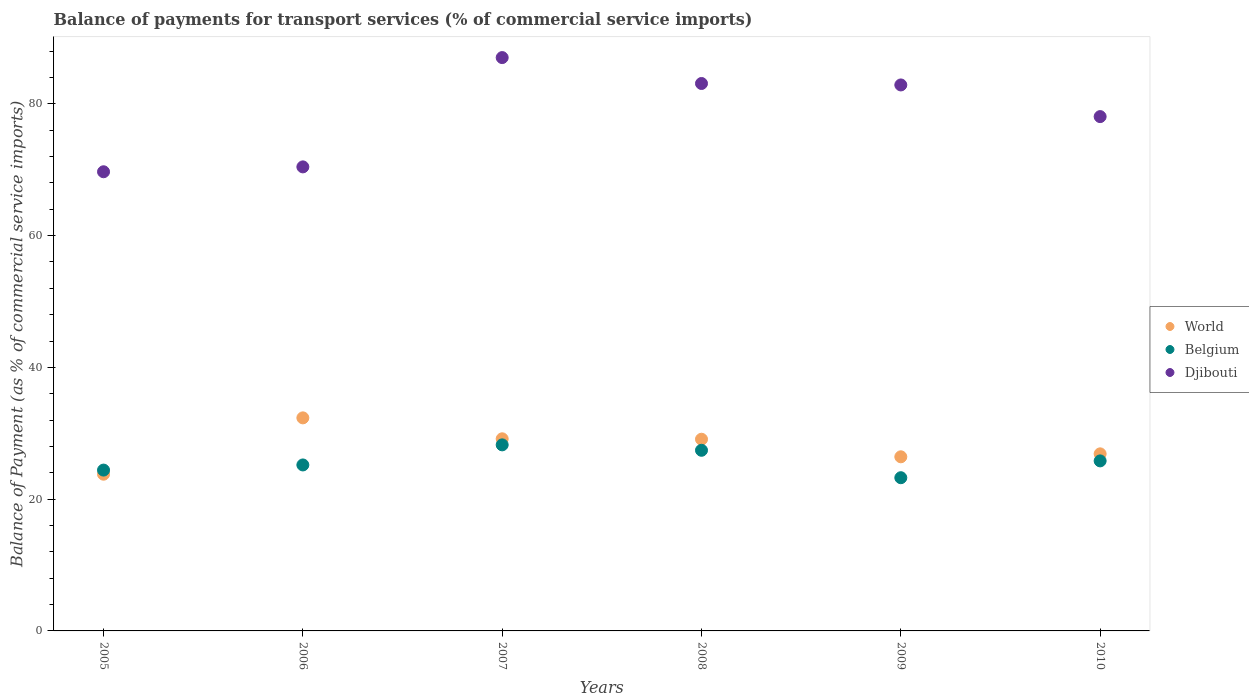How many different coloured dotlines are there?
Provide a succinct answer. 3. Is the number of dotlines equal to the number of legend labels?
Your answer should be compact. Yes. What is the balance of payments for transport services in Belgium in 2009?
Make the answer very short. 23.26. Across all years, what is the maximum balance of payments for transport services in World?
Ensure brevity in your answer.  32.34. Across all years, what is the minimum balance of payments for transport services in World?
Give a very brief answer. 23.79. What is the total balance of payments for transport services in Djibouti in the graph?
Provide a succinct answer. 471.19. What is the difference between the balance of payments for transport services in Djibouti in 2005 and that in 2006?
Your answer should be compact. -0.74. What is the difference between the balance of payments for transport services in World in 2006 and the balance of payments for transport services in Djibouti in 2009?
Offer a very short reply. -50.53. What is the average balance of payments for transport services in World per year?
Your response must be concise. 27.95. In the year 2006, what is the difference between the balance of payments for transport services in World and balance of payments for transport services in Belgium?
Offer a very short reply. 7.15. In how many years, is the balance of payments for transport services in World greater than 16 %?
Make the answer very short. 6. What is the ratio of the balance of payments for transport services in World in 2007 to that in 2010?
Keep it short and to the point. 1.08. Is the balance of payments for transport services in Belgium in 2009 less than that in 2010?
Make the answer very short. Yes. Is the difference between the balance of payments for transport services in World in 2005 and 2006 greater than the difference between the balance of payments for transport services in Belgium in 2005 and 2006?
Give a very brief answer. No. What is the difference between the highest and the second highest balance of payments for transport services in Belgium?
Offer a terse response. 0.82. What is the difference between the highest and the lowest balance of payments for transport services in Belgium?
Make the answer very short. 4.99. Is the sum of the balance of payments for transport services in Belgium in 2005 and 2008 greater than the maximum balance of payments for transport services in Djibouti across all years?
Give a very brief answer. No. Does the balance of payments for transport services in World monotonically increase over the years?
Provide a succinct answer. No. Is the balance of payments for transport services in Belgium strictly greater than the balance of payments for transport services in Djibouti over the years?
Give a very brief answer. No. How many dotlines are there?
Provide a succinct answer. 3. How many years are there in the graph?
Your response must be concise. 6. Are the values on the major ticks of Y-axis written in scientific E-notation?
Ensure brevity in your answer.  No. Where does the legend appear in the graph?
Keep it short and to the point. Center right. How many legend labels are there?
Offer a terse response. 3. How are the legend labels stacked?
Your answer should be very brief. Vertical. What is the title of the graph?
Offer a terse response. Balance of payments for transport services (% of commercial service imports). Does "Jordan" appear as one of the legend labels in the graph?
Your answer should be very brief. No. What is the label or title of the X-axis?
Your answer should be very brief. Years. What is the label or title of the Y-axis?
Your response must be concise. Balance of Payment (as % of commercial service imports). What is the Balance of Payment (as % of commercial service imports) in World in 2005?
Your response must be concise. 23.79. What is the Balance of Payment (as % of commercial service imports) in Belgium in 2005?
Your answer should be compact. 24.41. What is the Balance of Payment (as % of commercial service imports) in Djibouti in 2005?
Offer a terse response. 69.7. What is the Balance of Payment (as % of commercial service imports) of World in 2006?
Give a very brief answer. 32.34. What is the Balance of Payment (as % of commercial service imports) of Belgium in 2006?
Offer a terse response. 25.19. What is the Balance of Payment (as % of commercial service imports) in Djibouti in 2006?
Provide a short and direct response. 70.44. What is the Balance of Payment (as % of commercial service imports) of World in 2007?
Your answer should be very brief. 29.16. What is the Balance of Payment (as % of commercial service imports) of Belgium in 2007?
Offer a very short reply. 28.24. What is the Balance of Payment (as % of commercial service imports) in Djibouti in 2007?
Give a very brief answer. 87.03. What is the Balance of Payment (as % of commercial service imports) in World in 2008?
Provide a succinct answer. 29.1. What is the Balance of Payment (as % of commercial service imports) of Belgium in 2008?
Offer a very short reply. 27.42. What is the Balance of Payment (as % of commercial service imports) in Djibouti in 2008?
Provide a short and direct response. 83.09. What is the Balance of Payment (as % of commercial service imports) in World in 2009?
Your response must be concise. 26.43. What is the Balance of Payment (as % of commercial service imports) of Belgium in 2009?
Give a very brief answer. 23.26. What is the Balance of Payment (as % of commercial service imports) of Djibouti in 2009?
Your response must be concise. 82.87. What is the Balance of Payment (as % of commercial service imports) of World in 2010?
Your answer should be compact. 26.88. What is the Balance of Payment (as % of commercial service imports) in Belgium in 2010?
Make the answer very short. 25.81. What is the Balance of Payment (as % of commercial service imports) of Djibouti in 2010?
Provide a short and direct response. 78.07. Across all years, what is the maximum Balance of Payment (as % of commercial service imports) in World?
Offer a terse response. 32.34. Across all years, what is the maximum Balance of Payment (as % of commercial service imports) of Belgium?
Your response must be concise. 28.24. Across all years, what is the maximum Balance of Payment (as % of commercial service imports) in Djibouti?
Offer a very short reply. 87.03. Across all years, what is the minimum Balance of Payment (as % of commercial service imports) of World?
Ensure brevity in your answer.  23.79. Across all years, what is the minimum Balance of Payment (as % of commercial service imports) in Belgium?
Ensure brevity in your answer.  23.26. Across all years, what is the minimum Balance of Payment (as % of commercial service imports) in Djibouti?
Offer a very short reply. 69.7. What is the total Balance of Payment (as % of commercial service imports) in World in the graph?
Make the answer very short. 167.7. What is the total Balance of Payment (as % of commercial service imports) in Belgium in the graph?
Give a very brief answer. 154.33. What is the total Balance of Payment (as % of commercial service imports) of Djibouti in the graph?
Give a very brief answer. 471.19. What is the difference between the Balance of Payment (as % of commercial service imports) in World in 2005 and that in 2006?
Your response must be concise. -8.55. What is the difference between the Balance of Payment (as % of commercial service imports) in Belgium in 2005 and that in 2006?
Give a very brief answer. -0.78. What is the difference between the Balance of Payment (as % of commercial service imports) in Djibouti in 2005 and that in 2006?
Your answer should be very brief. -0.74. What is the difference between the Balance of Payment (as % of commercial service imports) in World in 2005 and that in 2007?
Provide a short and direct response. -5.37. What is the difference between the Balance of Payment (as % of commercial service imports) in Belgium in 2005 and that in 2007?
Ensure brevity in your answer.  -3.83. What is the difference between the Balance of Payment (as % of commercial service imports) in Djibouti in 2005 and that in 2007?
Your answer should be compact. -17.33. What is the difference between the Balance of Payment (as % of commercial service imports) of World in 2005 and that in 2008?
Your answer should be very brief. -5.31. What is the difference between the Balance of Payment (as % of commercial service imports) in Belgium in 2005 and that in 2008?
Your response must be concise. -3.01. What is the difference between the Balance of Payment (as % of commercial service imports) of Djibouti in 2005 and that in 2008?
Your answer should be compact. -13.4. What is the difference between the Balance of Payment (as % of commercial service imports) of World in 2005 and that in 2009?
Keep it short and to the point. -2.64. What is the difference between the Balance of Payment (as % of commercial service imports) of Belgium in 2005 and that in 2009?
Your answer should be very brief. 1.16. What is the difference between the Balance of Payment (as % of commercial service imports) of Djibouti in 2005 and that in 2009?
Offer a terse response. -13.18. What is the difference between the Balance of Payment (as % of commercial service imports) in World in 2005 and that in 2010?
Offer a terse response. -3.09. What is the difference between the Balance of Payment (as % of commercial service imports) of Belgium in 2005 and that in 2010?
Keep it short and to the point. -1.4. What is the difference between the Balance of Payment (as % of commercial service imports) of Djibouti in 2005 and that in 2010?
Keep it short and to the point. -8.37. What is the difference between the Balance of Payment (as % of commercial service imports) in World in 2006 and that in 2007?
Offer a terse response. 3.18. What is the difference between the Balance of Payment (as % of commercial service imports) of Belgium in 2006 and that in 2007?
Keep it short and to the point. -3.05. What is the difference between the Balance of Payment (as % of commercial service imports) in Djibouti in 2006 and that in 2007?
Give a very brief answer. -16.59. What is the difference between the Balance of Payment (as % of commercial service imports) in World in 2006 and that in 2008?
Make the answer very short. 3.24. What is the difference between the Balance of Payment (as % of commercial service imports) in Belgium in 2006 and that in 2008?
Offer a terse response. -2.22. What is the difference between the Balance of Payment (as % of commercial service imports) of Djibouti in 2006 and that in 2008?
Your answer should be compact. -12.66. What is the difference between the Balance of Payment (as % of commercial service imports) of World in 2006 and that in 2009?
Provide a succinct answer. 5.91. What is the difference between the Balance of Payment (as % of commercial service imports) in Belgium in 2006 and that in 2009?
Provide a short and direct response. 1.94. What is the difference between the Balance of Payment (as % of commercial service imports) of Djibouti in 2006 and that in 2009?
Give a very brief answer. -12.44. What is the difference between the Balance of Payment (as % of commercial service imports) in World in 2006 and that in 2010?
Your answer should be very brief. 5.46. What is the difference between the Balance of Payment (as % of commercial service imports) of Belgium in 2006 and that in 2010?
Your answer should be very brief. -0.61. What is the difference between the Balance of Payment (as % of commercial service imports) of Djibouti in 2006 and that in 2010?
Offer a very short reply. -7.63. What is the difference between the Balance of Payment (as % of commercial service imports) in World in 2007 and that in 2008?
Your answer should be compact. 0.06. What is the difference between the Balance of Payment (as % of commercial service imports) in Belgium in 2007 and that in 2008?
Give a very brief answer. 0.82. What is the difference between the Balance of Payment (as % of commercial service imports) in Djibouti in 2007 and that in 2008?
Make the answer very short. 3.93. What is the difference between the Balance of Payment (as % of commercial service imports) in World in 2007 and that in 2009?
Keep it short and to the point. 2.73. What is the difference between the Balance of Payment (as % of commercial service imports) in Belgium in 2007 and that in 2009?
Keep it short and to the point. 4.99. What is the difference between the Balance of Payment (as % of commercial service imports) in Djibouti in 2007 and that in 2009?
Offer a terse response. 4.15. What is the difference between the Balance of Payment (as % of commercial service imports) of World in 2007 and that in 2010?
Keep it short and to the point. 2.28. What is the difference between the Balance of Payment (as % of commercial service imports) in Belgium in 2007 and that in 2010?
Your answer should be compact. 2.43. What is the difference between the Balance of Payment (as % of commercial service imports) in Djibouti in 2007 and that in 2010?
Provide a short and direct response. 8.96. What is the difference between the Balance of Payment (as % of commercial service imports) in World in 2008 and that in 2009?
Provide a short and direct response. 2.67. What is the difference between the Balance of Payment (as % of commercial service imports) of Belgium in 2008 and that in 2009?
Provide a short and direct response. 4.16. What is the difference between the Balance of Payment (as % of commercial service imports) in Djibouti in 2008 and that in 2009?
Your answer should be very brief. 0.22. What is the difference between the Balance of Payment (as % of commercial service imports) of World in 2008 and that in 2010?
Make the answer very short. 2.22. What is the difference between the Balance of Payment (as % of commercial service imports) of Belgium in 2008 and that in 2010?
Offer a terse response. 1.61. What is the difference between the Balance of Payment (as % of commercial service imports) in Djibouti in 2008 and that in 2010?
Provide a succinct answer. 5.02. What is the difference between the Balance of Payment (as % of commercial service imports) of World in 2009 and that in 2010?
Keep it short and to the point. -0.45. What is the difference between the Balance of Payment (as % of commercial service imports) in Belgium in 2009 and that in 2010?
Your response must be concise. -2.55. What is the difference between the Balance of Payment (as % of commercial service imports) in Djibouti in 2009 and that in 2010?
Keep it short and to the point. 4.81. What is the difference between the Balance of Payment (as % of commercial service imports) of World in 2005 and the Balance of Payment (as % of commercial service imports) of Belgium in 2006?
Give a very brief answer. -1.4. What is the difference between the Balance of Payment (as % of commercial service imports) in World in 2005 and the Balance of Payment (as % of commercial service imports) in Djibouti in 2006?
Your answer should be compact. -46.65. What is the difference between the Balance of Payment (as % of commercial service imports) of Belgium in 2005 and the Balance of Payment (as % of commercial service imports) of Djibouti in 2006?
Your answer should be compact. -46.02. What is the difference between the Balance of Payment (as % of commercial service imports) of World in 2005 and the Balance of Payment (as % of commercial service imports) of Belgium in 2007?
Your answer should be very brief. -4.45. What is the difference between the Balance of Payment (as % of commercial service imports) of World in 2005 and the Balance of Payment (as % of commercial service imports) of Djibouti in 2007?
Offer a very short reply. -63.24. What is the difference between the Balance of Payment (as % of commercial service imports) of Belgium in 2005 and the Balance of Payment (as % of commercial service imports) of Djibouti in 2007?
Your answer should be very brief. -62.61. What is the difference between the Balance of Payment (as % of commercial service imports) in World in 2005 and the Balance of Payment (as % of commercial service imports) in Belgium in 2008?
Provide a succinct answer. -3.63. What is the difference between the Balance of Payment (as % of commercial service imports) of World in 2005 and the Balance of Payment (as % of commercial service imports) of Djibouti in 2008?
Provide a short and direct response. -59.3. What is the difference between the Balance of Payment (as % of commercial service imports) in Belgium in 2005 and the Balance of Payment (as % of commercial service imports) in Djibouti in 2008?
Your answer should be very brief. -58.68. What is the difference between the Balance of Payment (as % of commercial service imports) in World in 2005 and the Balance of Payment (as % of commercial service imports) in Belgium in 2009?
Provide a short and direct response. 0.53. What is the difference between the Balance of Payment (as % of commercial service imports) of World in 2005 and the Balance of Payment (as % of commercial service imports) of Djibouti in 2009?
Keep it short and to the point. -59.08. What is the difference between the Balance of Payment (as % of commercial service imports) of Belgium in 2005 and the Balance of Payment (as % of commercial service imports) of Djibouti in 2009?
Ensure brevity in your answer.  -58.46. What is the difference between the Balance of Payment (as % of commercial service imports) of World in 2005 and the Balance of Payment (as % of commercial service imports) of Belgium in 2010?
Your answer should be compact. -2.02. What is the difference between the Balance of Payment (as % of commercial service imports) in World in 2005 and the Balance of Payment (as % of commercial service imports) in Djibouti in 2010?
Offer a terse response. -54.28. What is the difference between the Balance of Payment (as % of commercial service imports) in Belgium in 2005 and the Balance of Payment (as % of commercial service imports) in Djibouti in 2010?
Give a very brief answer. -53.66. What is the difference between the Balance of Payment (as % of commercial service imports) of World in 2006 and the Balance of Payment (as % of commercial service imports) of Belgium in 2007?
Provide a short and direct response. 4.1. What is the difference between the Balance of Payment (as % of commercial service imports) in World in 2006 and the Balance of Payment (as % of commercial service imports) in Djibouti in 2007?
Your response must be concise. -54.69. What is the difference between the Balance of Payment (as % of commercial service imports) of Belgium in 2006 and the Balance of Payment (as % of commercial service imports) of Djibouti in 2007?
Ensure brevity in your answer.  -61.83. What is the difference between the Balance of Payment (as % of commercial service imports) of World in 2006 and the Balance of Payment (as % of commercial service imports) of Belgium in 2008?
Offer a very short reply. 4.92. What is the difference between the Balance of Payment (as % of commercial service imports) of World in 2006 and the Balance of Payment (as % of commercial service imports) of Djibouti in 2008?
Offer a very short reply. -50.75. What is the difference between the Balance of Payment (as % of commercial service imports) of Belgium in 2006 and the Balance of Payment (as % of commercial service imports) of Djibouti in 2008?
Your answer should be very brief. -57.9. What is the difference between the Balance of Payment (as % of commercial service imports) in World in 2006 and the Balance of Payment (as % of commercial service imports) in Belgium in 2009?
Provide a succinct answer. 9.08. What is the difference between the Balance of Payment (as % of commercial service imports) of World in 2006 and the Balance of Payment (as % of commercial service imports) of Djibouti in 2009?
Keep it short and to the point. -50.53. What is the difference between the Balance of Payment (as % of commercial service imports) of Belgium in 2006 and the Balance of Payment (as % of commercial service imports) of Djibouti in 2009?
Ensure brevity in your answer.  -57.68. What is the difference between the Balance of Payment (as % of commercial service imports) of World in 2006 and the Balance of Payment (as % of commercial service imports) of Belgium in 2010?
Your response must be concise. 6.53. What is the difference between the Balance of Payment (as % of commercial service imports) in World in 2006 and the Balance of Payment (as % of commercial service imports) in Djibouti in 2010?
Provide a succinct answer. -45.73. What is the difference between the Balance of Payment (as % of commercial service imports) in Belgium in 2006 and the Balance of Payment (as % of commercial service imports) in Djibouti in 2010?
Offer a terse response. -52.87. What is the difference between the Balance of Payment (as % of commercial service imports) in World in 2007 and the Balance of Payment (as % of commercial service imports) in Belgium in 2008?
Keep it short and to the point. 1.74. What is the difference between the Balance of Payment (as % of commercial service imports) of World in 2007 and the Balance of Payment (as % of commercial service imports) of Djibouti in 2008?
Make the answer very short. -53.93. What is the difference between the Balance of Payment (as % of commercial service imports) in Belgium in 2007 and the Balance of Payment (as % of commercial service imports) in Djibouti in 2008?
Your response must be concise. -54.85. What is the difference between the Balance of Payment (as % of commercial service imports) of World in 2007 and the Balance of Payment (as % of commercial service imports) of Belgium in 2009?
Your answer should be very brief. 5.91. What is the difference between the Balance of Payment (as % of commercial service imports) in World in 2007 and the Balance of Payment (as % of commercial service imports) in Djibouti in 2009?
Provide a succinct answer. -53.71. What is the difference between the Balance of Payment (as % of commercial service imports) in Belgium in 2007 and the Balance of Payment (as % of commercial service imports) in Djibouti in 2009?
Make the answer very short. -54.63. What is the difference between the Balance of Payment (as % of commercial service imports) in World in 2007 and the Balance of Payment (as % of commercial service imports) in Belgium in 2010?
Offer a very short reply. 3.35. What is the difference between the Balance of Payment (as % of commercial service imports) in World in 2007 and the Balance of Payment (as % of commercial service imports) in Djibouti in 2010?
Ensure brevity in your answer.  -48.91. What is the difference between the Balance of Payment (as % of commercial service imports) of Belgium in 2007 and the Balance of Payment (as % of commercial service imports) of Djibouti in 2010?
Your answer should be very brief. -49.83. What is the difference between the Balance of Payment (as % of commercial service imports) of World in 2008 and the Balance of Payment (as % of commercial service imports) of Belgium in 2009?
Ensure brevity in your answer.  5.84. What is the difference between the Balance of Payment (as % of commercial service imports) in World in 2008 and the Balance of Payment (as % of commercial service imports) in Djibouti in 2009?
Your response must be concise. -53.78. What is the difference between the Balance of Payment (as % of commercial service imports) of Belgium in 2008 and the Balance of Payment (as % of commercial service imports) of Djibouti in 2009?
Offer a very short reply. -55.46. What is the difference between the Balance of Payment (as % of commercial service imports) in World in 2008 and the Balance of Payment (as % of commercial service imports) in Belgium in 2010?
Provide a succinct answer. 3.29. What is the difference between the Balance of Payment (as % of commercial service imports) of World in 2008 and the Balance of Payment (as % of commercial service imports) of Djibouti in 2010?
Make the answer very short. -48.97. What is the difference between the Balance of Payment (as % of commercial service imports) of Belgium in 2008 and the Balance of Payment (as % of commercial service imports) of Djibouti in 2010?
Provide a short and direct response. -50.65. What is the difference between the Balance of Payment (as % of commercial service imports) of World in 2009 and the Balance of Payment (as % of commercial service imports) of Belgium in 2010?
Offer a very short reply. 0.62. What is the difference between the Balance of Payment (as % of commercial service imports) of World in 2009 and the Balance of Payment (as % of commercial service imports) of Djibouti in 2010?
Your answer should be very brief. -51.64. What is the difference between the Balance of Payment (as % of commercial service imports) of Belgium in 2009 and the Balance of Payment (as % of commercial service imports) of Djibouti in 2010?
Your answer should be very brief. -54.81. What is the average Balance of Payment (as % of commercial service imports) of World per year?
Your answer should be very brief. 27.95. What is the average Balance of Payment (as % of commercial service imports) in Belgium per year?
Give a very brief answer. 25.72. What is the average Balance of Payment (as % of commercial service imports) of Djibouti per year?
Offer a terse response. 78.53. In the year 2005, what is the difference between the Balance of Payment (as % of commercial service imports) in World and Balance of Payment (as % of commercial service imports) in Belgium?
Your response must be concise. -0.62. In the year 2005, what is the difference between the Balance of Payment (as % of commercial service imports) in World and Balance of Payment (as % of commercial service imports) in Djibouti?
Ensure brevity in your answer.  -45.91. In the year 2005, what is the difference between the Balance of Payment (as % of commercial service imports) in Belgium and Balance of Payment (as % of commercial service imports) in Djibouti?
Provide a succinct answer. -45.28. In the year 2006, what is the difference between the Balance of Payment (as % of commercial service imports) in World and Balance of Payment (as % of commercial service imports) in Belgium?
Your response must be concise. 7.15. In the year 2006, what is the difference between the Balance of Payment (as % of commercial service imports) of World and Balance of Payment (as % of commercial service imports) of Djibouti?
Your answer should be very brief. -38.1. In the year 2006, what is the difference between the Balance of Payment (as % of commercial service imports) of Belgium and Balance of Payment (as % of commercial service imports) of Djibouti?
Ensure brevity in your answer.  -45.24. In the year 2007, what is the difference between the Balance of Payment (as % of commercial service imports) in World and Balance of Payment (as % of commercial service imports) in Belgium?
Ensure brevity in your answer.  0.92. In the year 2007, what is the difference between the Balance of Payment (as % of commercial service imports) in World and Balance of Payment (as % of commercial service imports) in Djibouti?
Your response must be concise. -57.87. In the year 2007, what is the difference between the Balance of Payment (as % of commercial service imports) in Belgium and Balance of Payment (as % of commercial service imports) in Djibouti?
Offer a terse response. -58.78. In the year 2008, what is the difference between the Balance of Payment (as % of commercial service imports) in World and Balance of Payment (as % of commercial service imports) in Belgium?
Your answer should be compact. 1.68. In the year 2008, what is the difference between the Balance of Payment (as % of commercial service imports) in World and Balance of Payment (as % of commercial service imports) in Djibouti?
Provide a succinct answer. -54. In the year 2008, what is the difference between the Balance of Payment (as % of commercial service imports) of Belgium and Balance of Payment (as % of commercial service imports) of Djibouti?
Provide a short and direct response. -55.68. In the year 2009, what is the difference between the Balance of Payment (as % of commercial service imports) in World and Balance of Payment (as % of commercial service imports) in Belgium?
Provide a succinct answer. 3.17. In the year 2009, what is the difference between the Balance of Payment (as % of commercial service imports) of World and Balance of Payment (as % of commercial service imports) of Djibouti?
Offer a terse response. -56.44. In the year 2009, what is the difference between the Balance of Payment (as % of commercial service imports) in Belgium and Balance of Payment (as % of commercial service imports) in Djibouti?
Your answer should be very brief. -59.62. In the year 2010, what is the difference between the Balance of Payment (as % of commercial service imports) of World and Balance of Payment (as % of commercial service imports) of Belgium?
Give a very brief answer. 1.07. In the year 2010, what is the difference between the Balance of Payment (as % of commercial service imports) in World and Balance of Payment (as % of commercial service imports) in Djibouti?
Offer a terse response. -51.19. In the year 2010, what is the difference between the Balance of Payment (as % of commercial service imports) of Belgium and Balance of Payment (as % of commercial service imports) of Djibouti?
Your answer should be compact. -52.26. What is the ratio of the Balance of Payment (as % of commercial service imports) of World in 2005 to that in 2006?
Your response must be concise. 0.74. What is the ratio of the Balance of Payment (as % of commercial service imports) of Belgium in 2005 to that in 2006?
Your answer should be compact. 0.97. What is the ratio of the Balance of Payment (as % of commercial service imports) of World in 2005 to that in 2007?
Your response must be concise. 0.82. What is the ratio of the Balance of Payment (as % of commercial service imports) of Belgium in 2005 to that in 2007?
Ensure brevity in your answer.  0.86. What is the ratio of the Balance of Payment (as % of commercial service imports) in Djibouti in 2005 to that in 2007?
Give a very brief answer. 0.8. What is the ratio of the Balance of Payment (as % of commercial service imports) in World in 2005 to that in 2008?
Ensure brevity in your answer.  0.82. What is the ratio of the Balance of Payment (as % of commercial service imports) of Belgium in 2005 to that in 2008?
Offer a very short reply. 0.89. What is the ratio of the Balance of Payment (as % of commercial service imports) of Djibouti in 2005 to that in 2008?
Provide a short and direct response. 0.84. What is the ratio of the Balance of Payment (as % of commercial service imports) of World in 2005 to that in 2009?
Your answer should be compact. 0.9. What is the ratio of the Balance of Payment (as % of commercial service imports) of Belgium in 2005 to that in 2009?
Your answer should be very brief. 1.05. What is the ratio of the Balance of Payment (as % of commercial service imports) of Djibouti in 2005 to that in 2009?
Your answer should be very brief. 0.84. What is the ratio of the Balance of Payment (as % of commercial service imports) in World in 2005 to that in 2010?
Your answer should be compact. 0.89. What is the ratio of the Balance of Payment (as % of commercial service imports) in Belgium in 2005 to that in 2010?
Your answer should be compact. 0.95. What is the ratio of the Balance of Payment (as % of commercial service imports) of Djibouti in 2005 to that in 2010?
Make the answer very short. 0.89. What is the ratio of the Balance of Payment (as % of commercial service imports) in World in 2006 to that in 2007?
Keep it short and to the point. 1.11. What is the ratio of the Balance of Payment (as % of commercial service imports) of Belgium in 2006 to that in 2007?
Offer a terse response. 0.89. What is the ratio of the Balance of Payment (as % of commercial service imports) in Djibouti in 2006 to that in 2007?
Provide a short and direct response. 0.81. What is the ratio of the Balance of Payment (as % of commercial service imports) of World in 2006 to that in 2008?
Offer a terse response. 1.11. What is the ratio of the Balance of Payment (as % of commercial service imports) in Belgium in 2006 to that in 2008?
Your answer should be compact. 0.92. What is the ratio of the Balance of Payment (as % of commercial service imports) in Djibouti in 2006 to that in 2008?
Provide a short and direct response. 0.85. What is the ratio of the Balance of Payment (as % of commercial service imports) of World in 2006 to that in 2009?
Give a very brief answer. 1.22. What is the ratio of the Balance of Payment (as % of commercial service imports) in Belgium in 2006 to that in 2009?
Provide a short and direct response. 1.08. What is the ratio of the Balance of Payment (as % of commercial service imports) of Djibouti in 2006 to that in 2009?
Your response must be concise. 0.85. What is the ratio of the Balance of Payment (as % of commercial service imports) in World in 2006 to that in 2010?
Ensure brevity in your answer.  1.2. What is the ratio of the Balance of Payment (as % of commercial service imports) of Belgium in 2006 to that in 2010?
Provide a short and direct response. 0.98. What is the ratio of the Balance of Payment (as % of commercial service imports) of Djibouti in 2006 to that in 2010?
Your answer should be very brief. 0.9. What is the ratio of the Balance of Payment (as % of commercial service imports) in World in 2007 to that in 2008?
Provide a succinct answer. 1. What is the ratio of the Balance of Payment (as % of commercial service imports) of Belgium in 2007 to that in 2008?
Offer a terse response. 1.03. What is the ratio of the Balance of Payment (as % of commercial service imports) in Djibouti in 2007 to that in 2008?
Keep it short and to the point. 1.05. What is the ratio of the Balance of Payment (as % of commercial service imports) of World in 2007 to that in 2009?
Make the answer very short. 1.1. What is the ratio of the Balance of Payment (as % of commercial service imports) of Belgium in 2007 to that in 2009?
Ensure brevity in your answer.  1.21. What is the ratio of the Balance of Payment (as % of commercial service imports) in Djibouti in 2007 to that in 2009?
Your answer should be very brief. 1.05. What is the ratio of the Balance of Payment (as % of commercial service imports) of World in 2007 to that in 2010?
Offer a terse response. 1.08. What is the ratio of the Balance of Payment (as % of commercial service imports) in Belgium in 2007 to that in 2010?
Your answer should be compact. 1.09. What is the ratio of the Balance of Payment (as % of commercial service imports) in Djibouti in 2007 to that in 2010?
Provide a short and direct response. 1.11. What is the ratio of the Balance of Payment (as % of commercial service imports) of World in 2008 to that in 2009?
Make the answer very short. 1.1. What is the ratio of the Balance of Payment (as % of commercial service imports) in Belgium in 2008 to that in 2009?
Your response must be concise. 1.18. What is the ratio of the Balance of Payment (as % of commercial service imports) of Djibouti in 2008 to that in 2009?
Your response must be concise. 1. What is the ratio of the Balance of Payment (as % of commercial service imports) of World in 2008 to that in 2010?
Give a very brief answer. 1.08. What is the ratio of the Balance of Payment (as % of commercial service imports) in Belgium in 2008 to that in 2010?
Your response must be concise. 1.06. What is the ratio of the Balance of Payment (as % of commercial service imports) of Djibouti in 2008 to that in 2010?
Your response must be concise. 1.06. What is the ratio of the Balance of Payment (as % of commercial service imports) of World in 2009 to that in 2010?
Provide a succinct answer. 0.98. What is the ratio of the Balance of Payment (as % of commercial service imports) in Belgium in 2009 to that in 2010?
Give a very brief answer. 0.9. What is the ratio of the Balance of Payment (as % of commercial service imports) in Djibouti in 2009 to that in 2010?
Your response must be concise. 1.06. What is the difference between the highest and the second highest Balance of Payment (as % of commercial service imports) of World?
Your answer should be very brief. 3.18. What is the difference between the highest and the second highest Balance of Payment (as % of commercial service imports) of Belgium?
Offer a very short reply. 0.82. What is the difference between the highest and the second highest Balance of Payment (as % of commercial service imports) of Djibouti?
Provide a short and direct response. 3.93. What is the difference between the highest and the lowest Balance of Payment (as % of commercial service imports) of World?
Offer a very short reply. 8.55. What is the difference between the highest and the lowest Balance of Payment (as % of commercial service imports) in Belgium?
Keep it short and to the point. 4.99. What is the difference between the highest and the lowest Balance of Payment (as % of commercial service imports) in Djibouti?
Give a very brief answer. 17.33. 